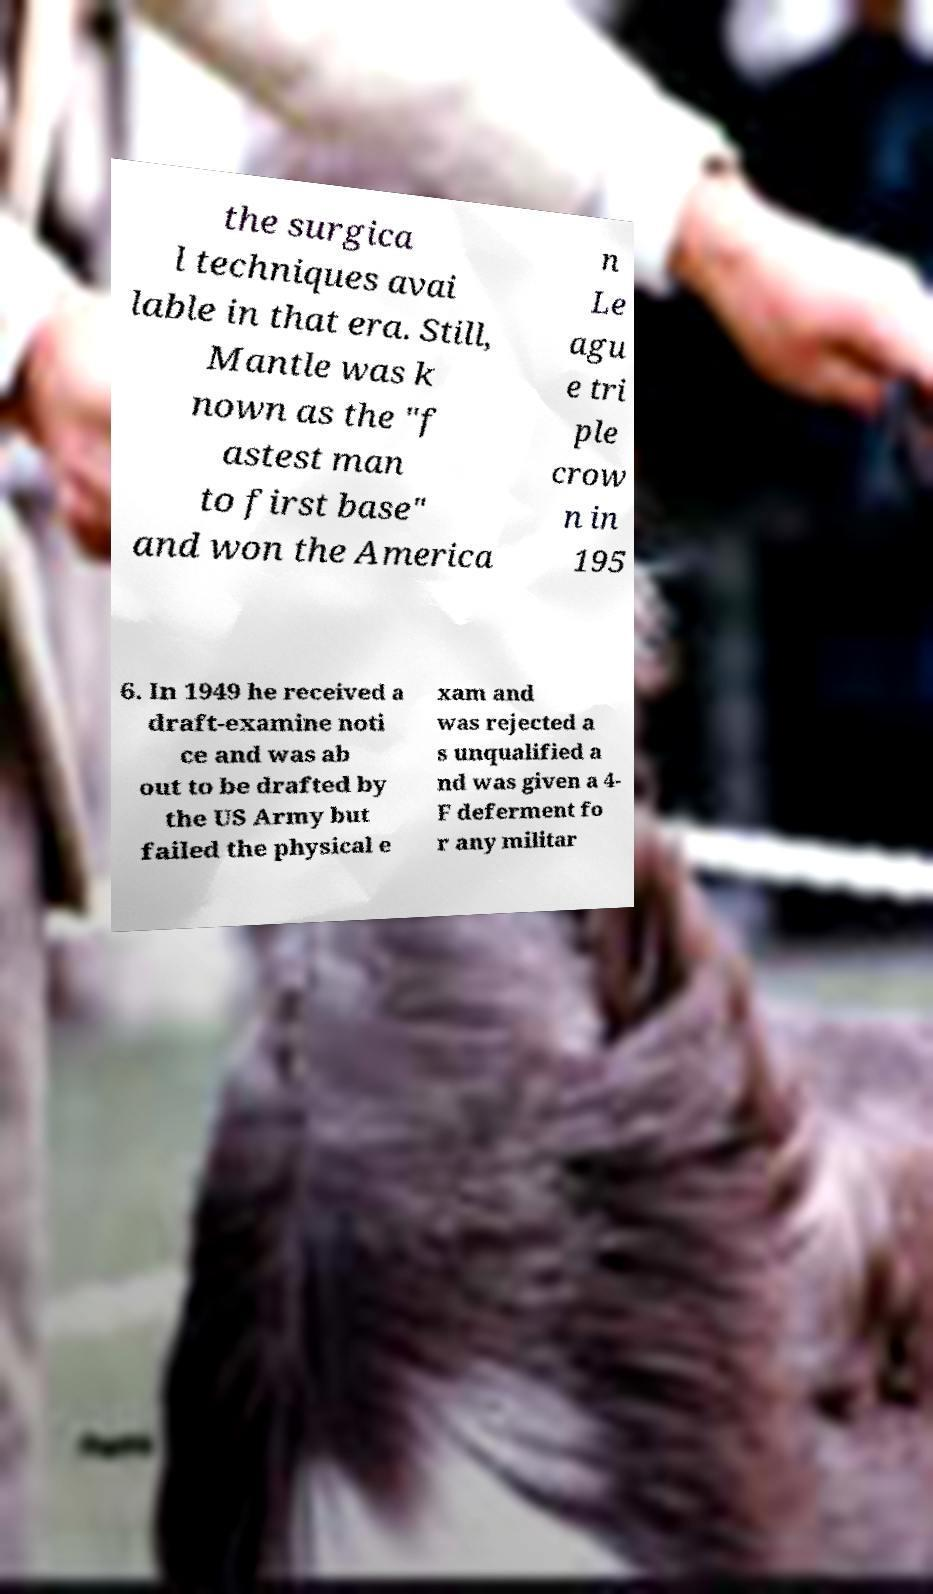For documentation purposes, I need the text within this image transcribed. Could you provide that? the surgica l techniques avai lable in that era. Still, Mantle was k nown as the "f astest man to first base" and won the America n Le agu e tri ple crow n in 195 6. In 1949 he received a draft-examine noti ce and was ab out to be drafted by the US Army but failed the physical e xam and was rejected a s unqualified a nd was given a 4- F deferment fo r any militar 